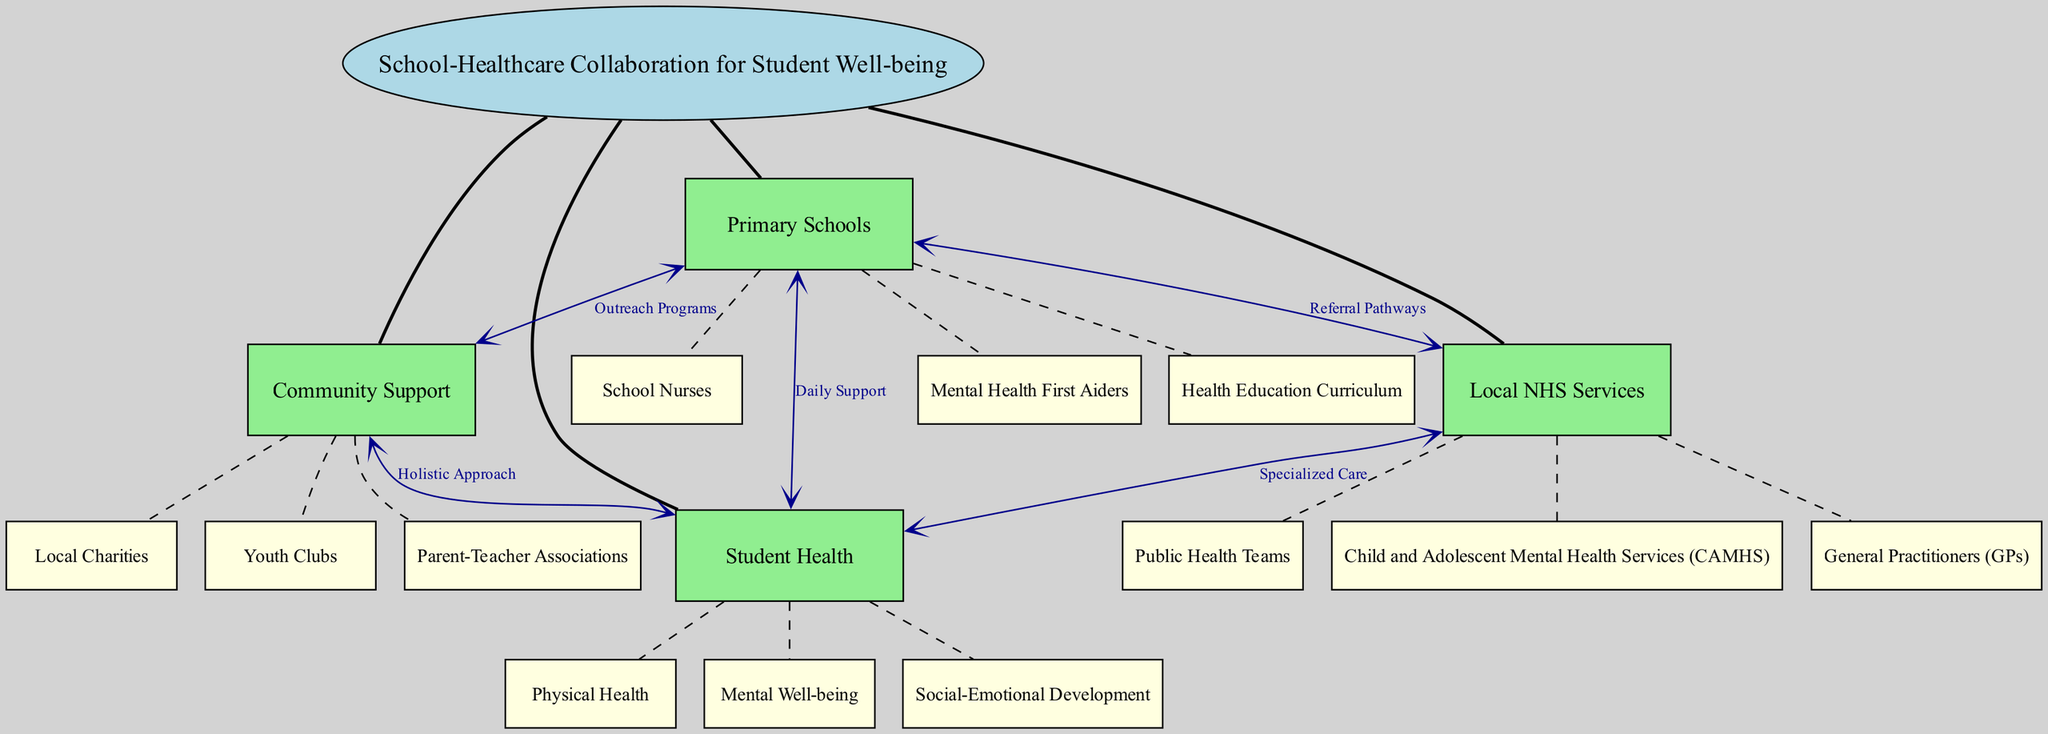What is the central concept of the diagram? The central concept is indicated at the top of the diagram and serves as the focal point from which all other nodes radiate. It directly states "School-Healthcare Collaboration for Student Well-being."
Answer: School-Healthcare Collaboration for Student well-being How many main nodes are there in the diagram? The main nodes are listed as the primary categories branching out from the central concept. Counting them gives a total of four main nodes: "Primary Schools," "Local NHS Services," "Student Health," and "Community Support."
Answer: 4 Which node is connected to "Child and Adolescent Mental Health Services (CAMHS)"? The connection from "Child and Adolescent Mental Health Services (CAMHS)" can be traced to the upper node, "Local NHS Services," which is the parent node for this sub-node.
Answer: Local NHS Services What type of support do “Primary Schools” provide to “Student Health”? Referring to the connections illustrated, "Primary Schools" provide "Daily Support" to "Student Health," indicating ongoing assistance in various health-related areas.
Answer: Daily Support What is the relationship between "Community Support" and "Student Health"? The diagram explicitly states the connection with the label "Holistic Approach," suggesting that "Community Support" contributes to the overall well-being of "Student Health" through diverse, integrated resources.
Answer: Holistic Approach Which node provides specialized care to students? "Local NHS Services" is the node that offers "Specialized Care," as shown in the diagram, meaning it is responsible for more focused health interventions.
Answer: Local NHS Services How does "Primary Schools" connect to "Local NHS Services"? The diagram illustrates this relationship through "Referral Pathways," which outlines the structured way in which schools can refer students to healthcare services when needed.
Answer: Referral Pathways Which community organization is involved in supporting student well-being? Among the listed elements under "Community Support," "Local Charities" is one organization that plays a key role in supporting student well-being, highlighting community involvement.
Answer: Local Charities What is the purpose of “Outreach Programs” in the context of the diagram? The term "Outreach Programs," connected from "Primary Schools" to "Community Support," signifies efforts made by schools to engage with families and community organizations to enhance student support.
Answer: Outreach Programs 